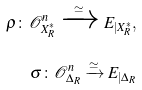Convert formula to latex. <formula><loc_0><loc_0><loc_500><loc_500>\rho \colon \mathcal { O } _ { X _ { R } ^ { * } } ^ { n } \xrightarrow { \simeq } E _ { | X ^ { * } _ { R } } , \\ \sigma \colon \mathcal { O } _ { \Delta _ { R } } ^ { n } \xrightarrow { \simeq } E _ { | \Delta _ { R } }</formula> 